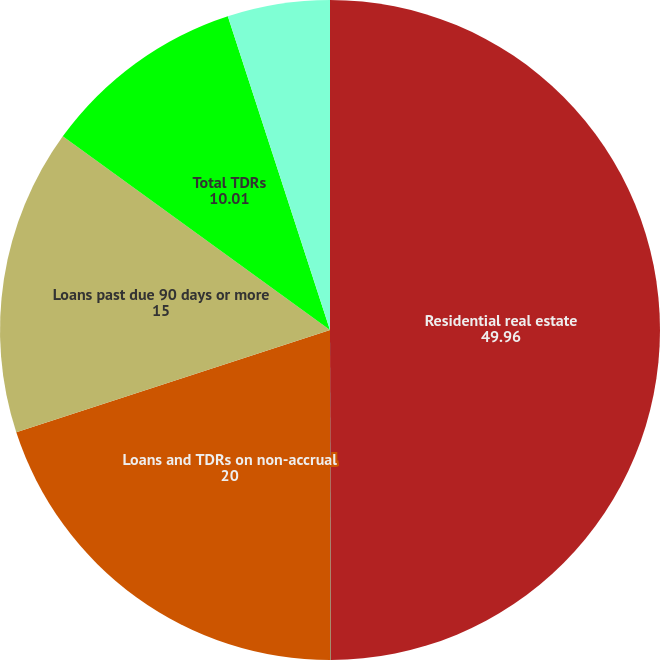<chart> <loc_0><loc_0><loc_500><loc_500><pie_chart><fcel>Residential real estate<fcel>Home equity lines of credit<fcel>Loans and TDRs on non-accrual<fcel>Loans past due 90 days or more<fcel>Total TDRs<fcel>Interest income recorded on<nl><fcel>49.96%<fcel>0.02%<fcel>20.0%<fcel>15.0%<fcel>10.01%<fcel>5.01%<nl></chart> 